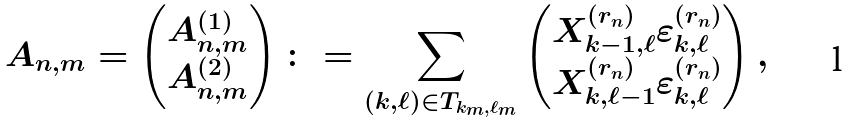<formula> <loc_0><loc_0><loc_500><loc_500>A _ { n , m } = \begin{pmatrix} A _ { n , m } ^ { ( 1 ) } \\ A _ { n , m } ^ { ( 2 ) } \end{pmatrix} \colon = \sum _ { ( k , \ell ) \in T _ { k _ { m } , \ell _ { m } } } \begin{pmatrix} X _ { k - 1 , \ell } ^ { ( r _ { n } ) } \varepsilon _ { k , \ell } ^ { ( r _ { n } ) } \\ X _ { k , \ell - 1 } ^ { ( r _ { n } ) } \varepsilon _ { k , \ell } ^ { ( r _ { n } ) } \end{pmatrix} ,</formula> 